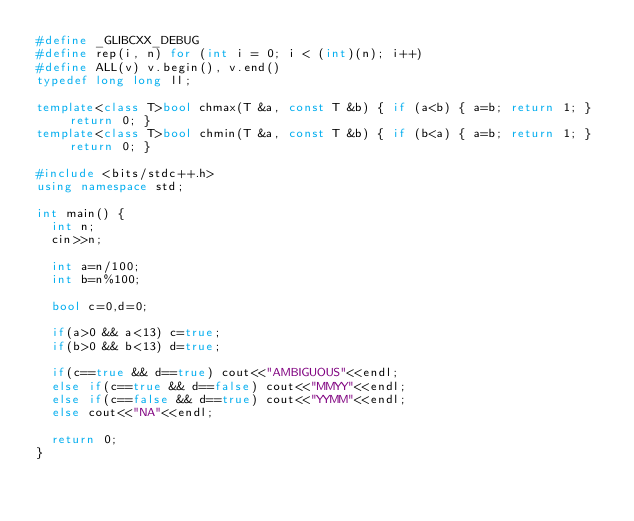<code> <loc_0><loc_0><loc_500><loc_500><_C++_>#define _GLIBCXX_DEBUG
#define rep(i, n) for (int i = 0; i < (int)(n); i++)
#define ALL(v) v.begin(), v.end()
typedef long long ll;

template<class T>bool chmax(T &a, const T &b) { if (a<b) { a=b; return 1; } return 0; }
template<class T>bool chmin(T &a, const T &b) { if (b<a) { a=b; return 1; } return 0; }

#include <bits/stdc++.h>
using namespace std;

int main() {
  int n;
  cin>>n;
  
  int a=n/100;
  int b=n%100;
  
  bool c=0,d=0;
  
  if(a>0 && a<13) c=true;
  if(b>0 && b<13) d=true;
  
  if(c==true && d==true) cout<<"AMBIGUOUS"<<endl;
  else if(c==true && d==false) cout<<"MMYY"<<endl;
  else if(c==false && d==true) cout<<"YYMM"<<endl;
  else cout<<"NA"<<endl;

  return 0;
}</code> 